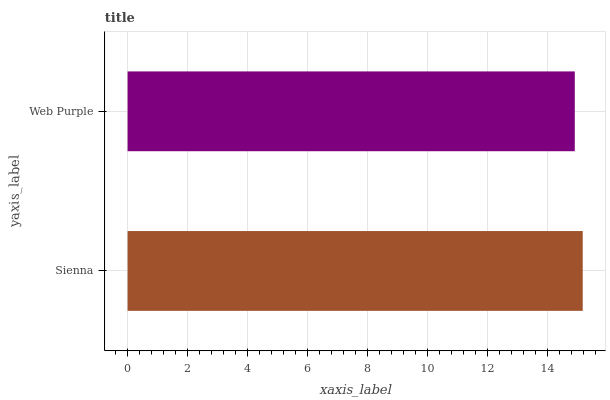Is Web Purple the minimum?
Answer yes or no. Yes. Is Sienna the maximum?
Answer yes or no. Yes. Is Web Purple the maximum?
Answer yes or no. No. Is Sienna greater than Web Purple?
Answer yes or no. Yes. Is Web Purple less than Sienna?
Answer yes or no. Yes. Is Web Purple greater than Sienna?
Answer yes or no. No. Is Sienna less than Web Purple?
Answer yes or no. No. Is Sienna the high median?
Answer yes or no. Yes. Is Web Purple the low median?
Answer yes or no. Yes. Is Web Purple the high median?
Answer yes or no. No. Is Sienna the low median?
Answer yes or no. No. 